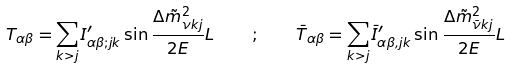<formula> <loc_0><loc_0><loc_500><loc_500>T _ { \alpha \beta } = \sum _ { k > j } I ^ { \prime } _ { \alpha \beta ; j k } \sin \frac { \Delta \tilde { m } ^ { 2 } _ { \nu k j } } { 2 E } L \quad ; \quad \bar { T } _ { \alpha \beta } = \sum _ { k > j } \bar { I } ^ { \prime } _ { \alpha \beta , j k } \sin \frac { \Delta \tilde { m } ^ { 2 } _ { \bar { \nu } k j } } { 2 E } L</formula> 